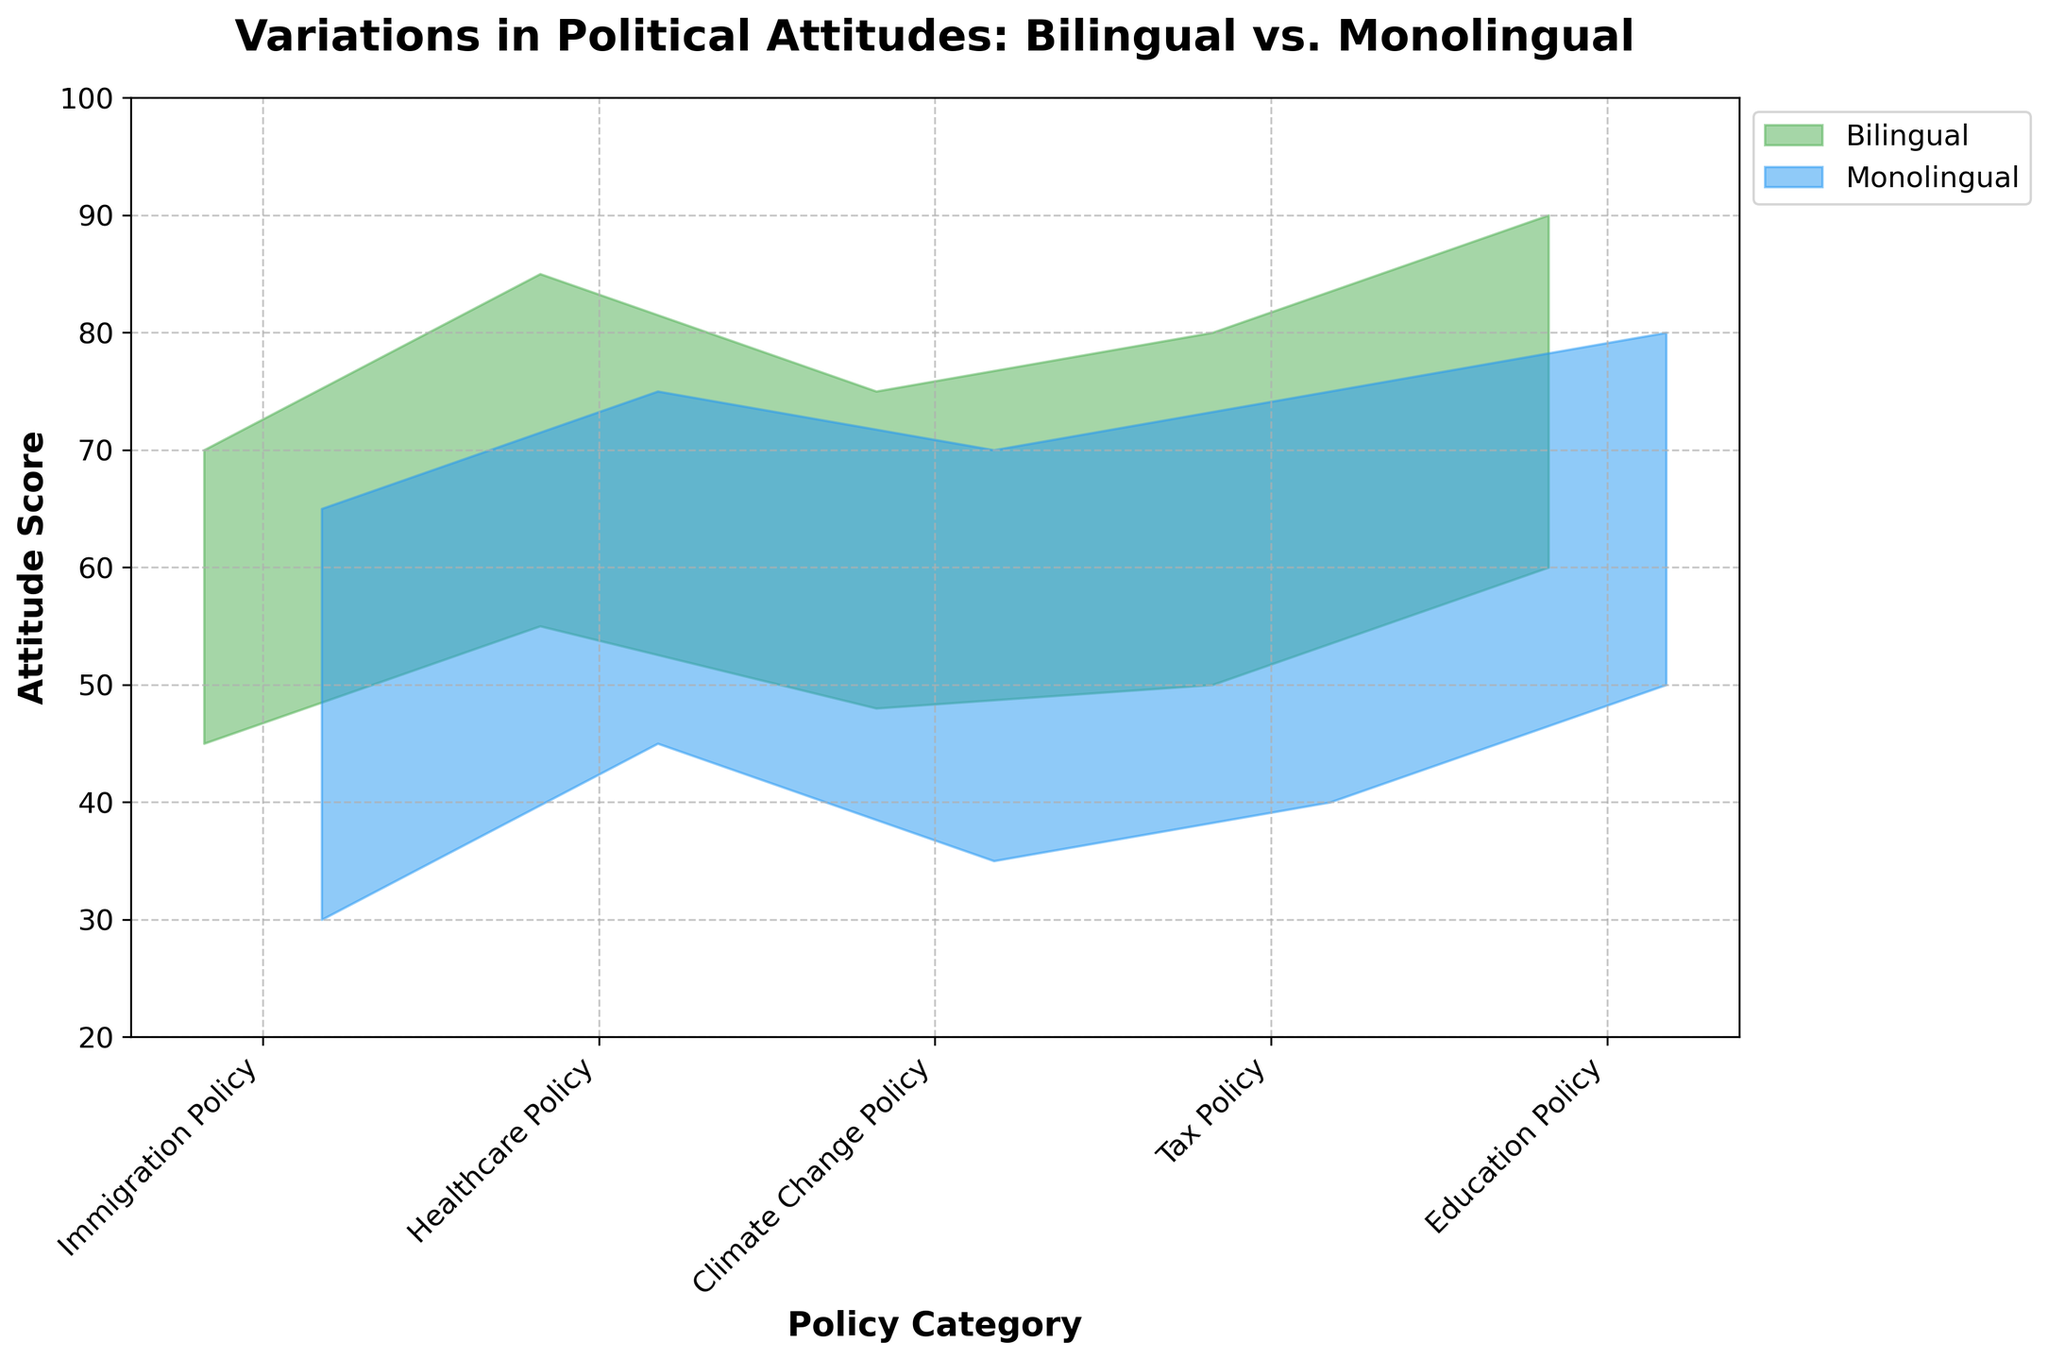what is the range of attitude scores for immigration policy among monolinguals? The range is calculated by subtracting the minimum attitude score from the maximum attitude score. For monolinguals in immigration policy, the scores range from 30 to 65. Thus, the range is 65 - 30 = 35.
Answer: 35 What is the title of the chart? The title of the chart is located at the top.
Answer: Variations in Political Attitudes: Bilingual vs. Monolingual Which policy category shows the highest maximum attitude score among bilinguals? Scan the maximum attitude scores for bilinguals across all policy categories. The highest maximum score is 90 in the Education Policy category.
Answer: Education Policy What is the average minimum attitude score for monolinguals across all policy categories? Sum the minimum attitude scores for monolinguals (30+45+35+40+50) and divide by the number of categories (5). (30+45+35+40+50)/5 = 200/5 = 40
Answer: 40 How does the range of attitude scores for healthcare policy compare between bilinguals and monolinguals? Calculate the range for healthcare policy for both groups. Bilingual range: 85-55=30, Monolingual range: 75-45=30. Both ranges are equal.
Answer: Equal Which policy category has the largest difference in maximum attitude scores between bilinguals and monolinguals? For each category, calculate the difference between the maximum scores of bilinguals and monolinguals: Immigration policy (5), Healthcare policy (10), Climate change policy (5), Tax policy (5), Education policy (10). The largest difference is 10, observed in Healthcare and Education policies.
Answer: Healthcare and Education Policy Which group has a wider range of attitude scores in climate change policy? Compare the ranges for both groups in the climate change policy. Bilingual range: 75-48=27, Monolingual range: 70-35=35. Monolinguals have a wider range.
Answer: Monolinguals What are the plotted colors for bilingual and monolingual groups? The visual elements in the figure show that bilinguals are plotted in a shade of green and monolinguals are plotted in a shade of blue.
Answer: Green and Blue Is the minimum score for tax policy higher for bilinguals or monolinguals? Compare the minimum attitude scores for tax policy. Bilinguals: 50, Monolinguals: 40. Bilinguals have a higher minimum score.
Answer: Bilinguals What are the attitude score ranges for education policy for both groups? For bilinguals, the range is from 60 to 90. For monolinguals, the range is from 50 to 80. Therefore, the ranges are (60-90) and (50-80), respectively.
Answer: 60-90 for bilinguals, 50-80 for monolinguals 